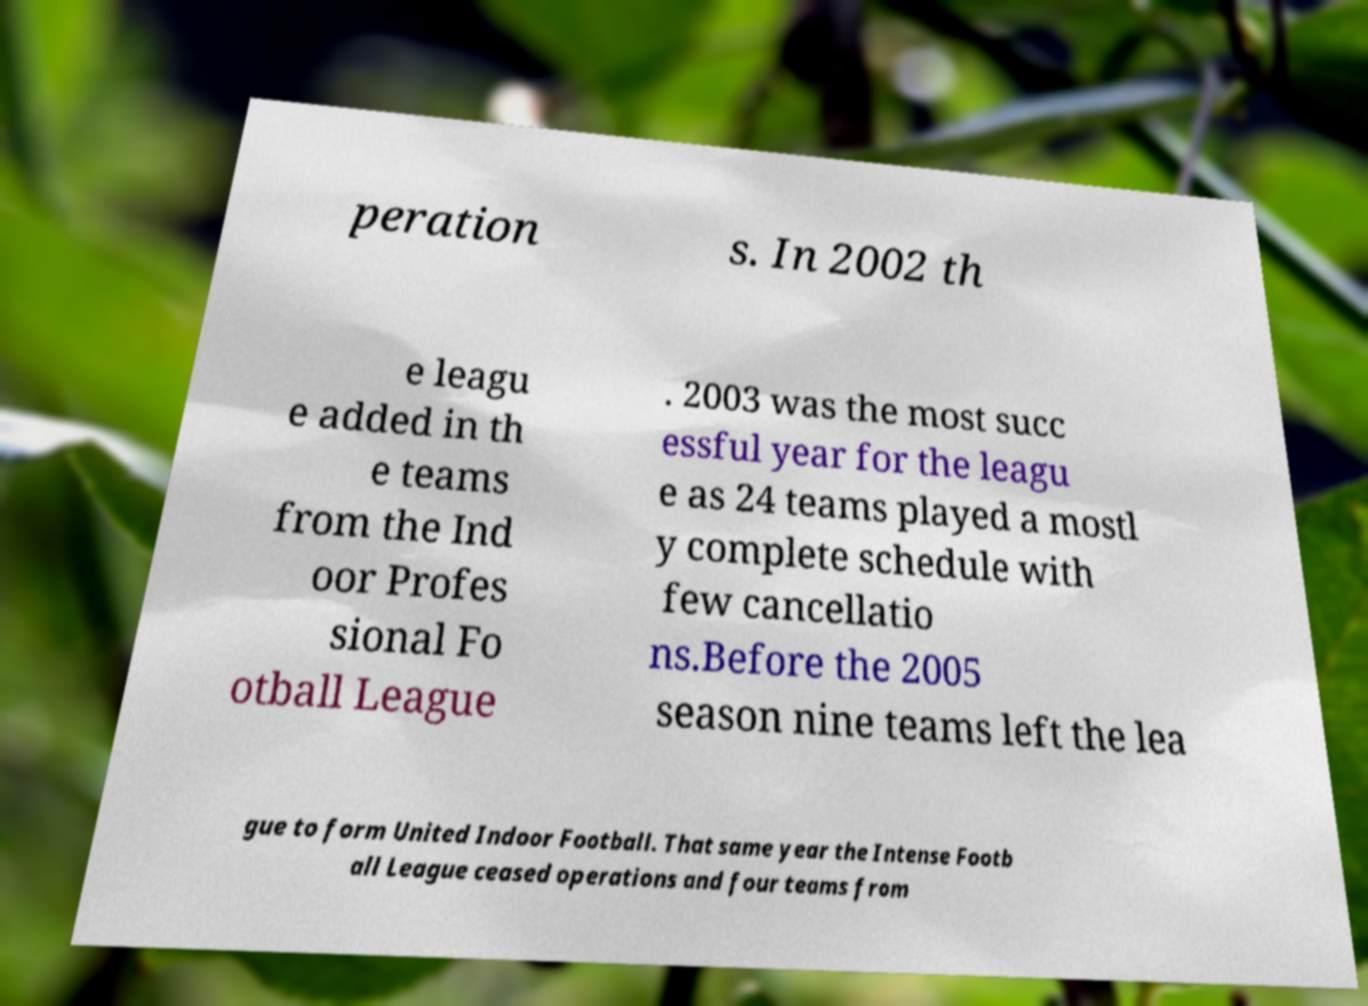Can you accurately transcribe the text from the provided image for me? peration s. In 2002 th e leagu e added in th e teams from the Ind oor Profes sional Fo otball League . 2003 was the most succ essful year for the leagu e as 24 teams played a mostl y complete schedule with few cancellatio ns.Before the 2005 season nine teams left the lea gue to form United Indoor Football. That same year the Intense Footb all League ceased operations and four teams from 